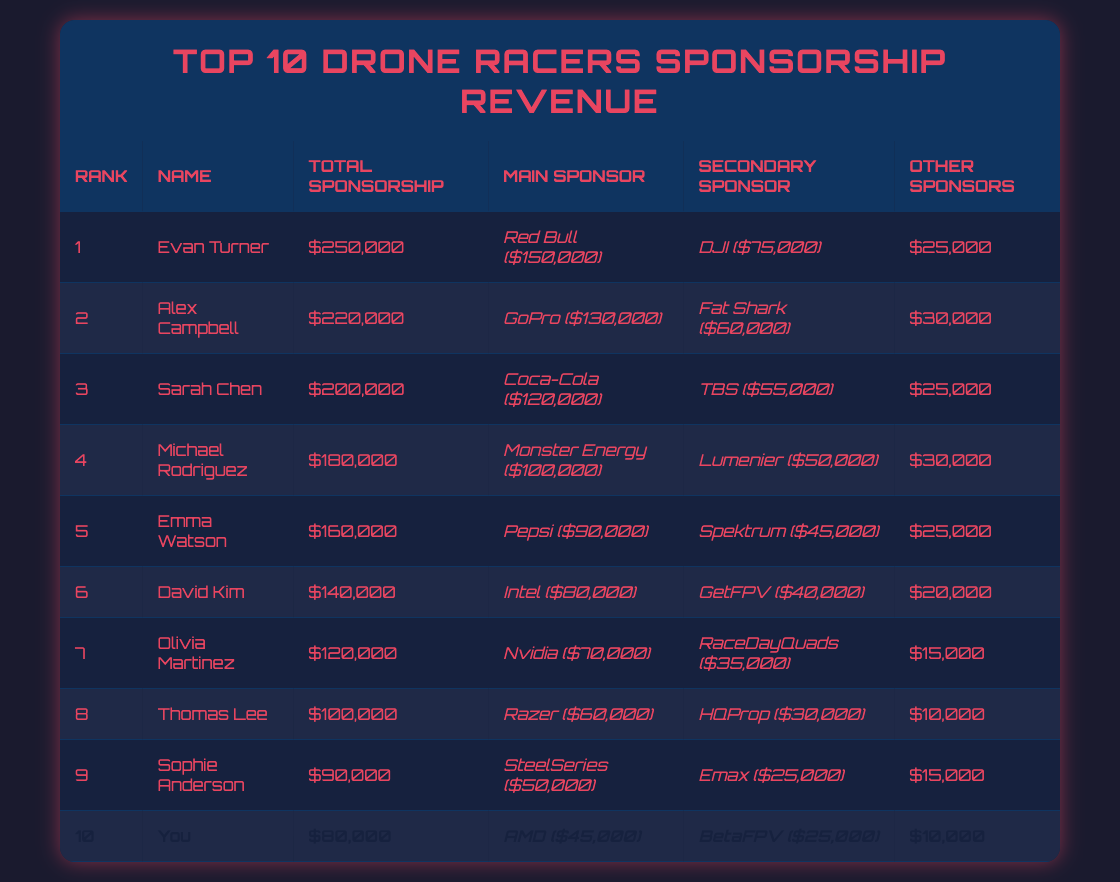What is the total sponsorship amount for Evan Turner? Evan Turner is ranked 1st in the table, and his total sponsorship amount is listed as $250,000.
Answer: $250,000 How much does Alex Campbell earn from his main sponsor? Alex Campbell, who is ranked 2nd, has a main sponsor, GoPro, which contributes $130,000 according to the table.
Answer: $130,000 Which racer has the lowest total sponsorship? The table lists "You" in rank 10 with a total sponsorship amount of $80,000, which is the lowest among all listed racers.
Answer: You What is the average total sponsorship amount of the top 5 racers? To find the average for the top 5 racers: (250000 + 220000 + 200000 + 180000 + 160000) = 1110000. Dividing by 5 gives an average of 222000.
Answer: $222,000 Is Emma Watson's total sponsorship greater than David Kim's? Emma Watson has a total sponsorship of $160,000 while David Kim has $140,000, which means Emma Watson's sponsorship is indeed greater.
Answer: Yes How much does Sophie Anderson earn from her secondary sponsor? Sophie Anderson, who is ranked 9th, has a secondary sponsor Emax that contributes $25,000 as noted in the table.
Answer: $25,000 What is the difference in total sponsorship between Sarah Chen and Michael Rodriguez? Sarah Chen has a total sponsorship of $200,000 and Michael Rodriguez has $180,000. The difference is calculated as $200,000 - $180,000 = $20,000.
Answer: $20,000 Which main sponsor accounts for the highest contribution in total sponsorship? Evan Turner's main sponsor Red Bull contributes the highest amount of $150,000, which is the most significant single contribution from any main sponsor among the racers.
Answer: Red Bull Calculate the total sponsorship for all racers combined. To find the total, sum each racer’s total sponsorship amounts: 250000 + 220000 + 200000 + 180000 + 160000 + 140000 + 120000 + 100000 + 90000 + 80000 = 1,540,000.
Answer: $1,540,000 